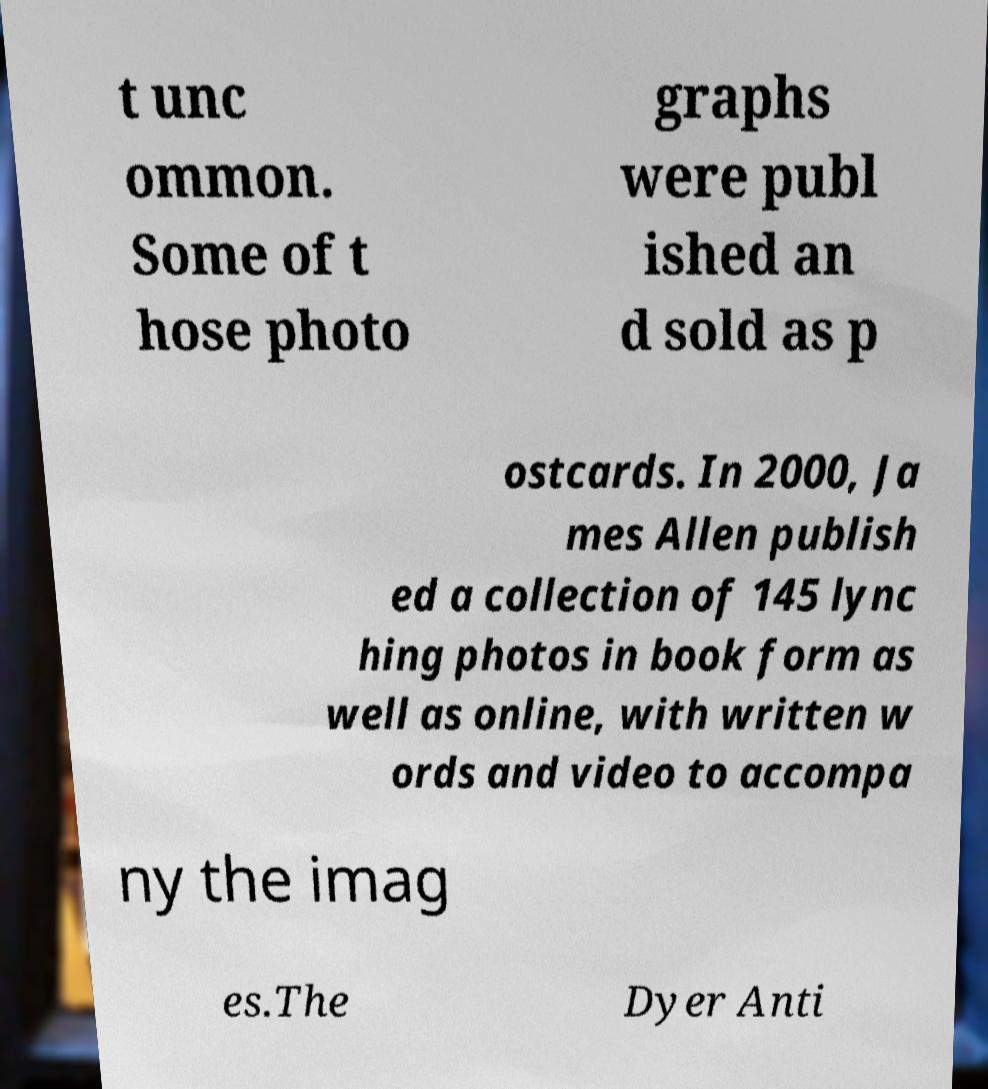For documentation purposes, I need the text within this image transcribed. Could you provide that? t unc ommon. Some of t hose photo graphs were publ ished an d sold as p ostcards. In 2000, Ja mes Allen publish ed a collection of 145 lync hing photos in book form as well as online, with written w ords and video to accompa ny the imag es.The Dyer Anti 